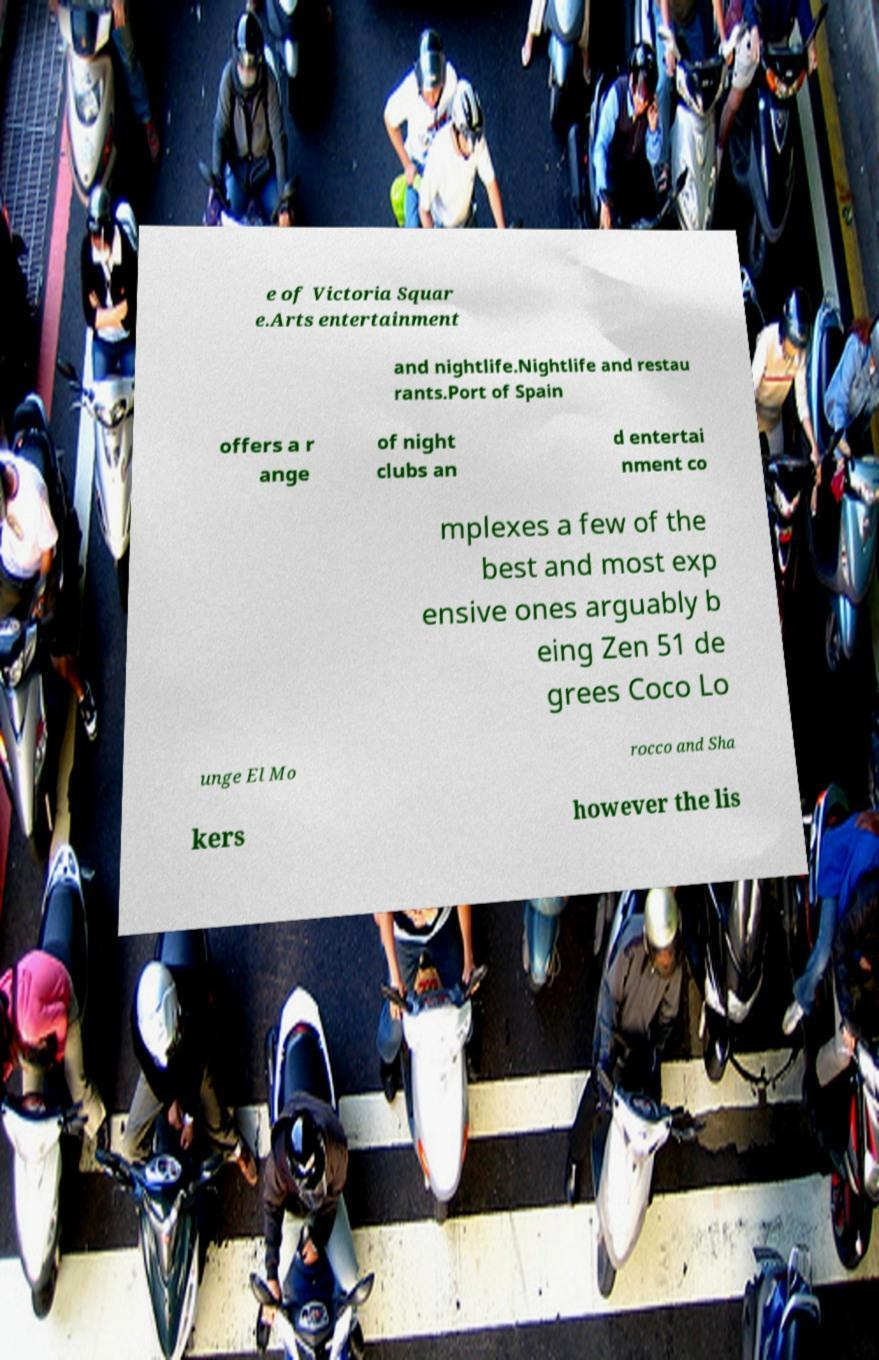Could you assist in decoding the text presented in this image and type it out clearly? e of Victoria Squar e.Arts entertainment and nightlife.Nightlife and restau rants.Port of Spain offers a r ange of night clubs an d entertai nment co mplexes a few of the best and most exp ensive ones arguably b eing Zen 51 de grees Coco Lo unge El Mo rocco and Sha kers however the lis 